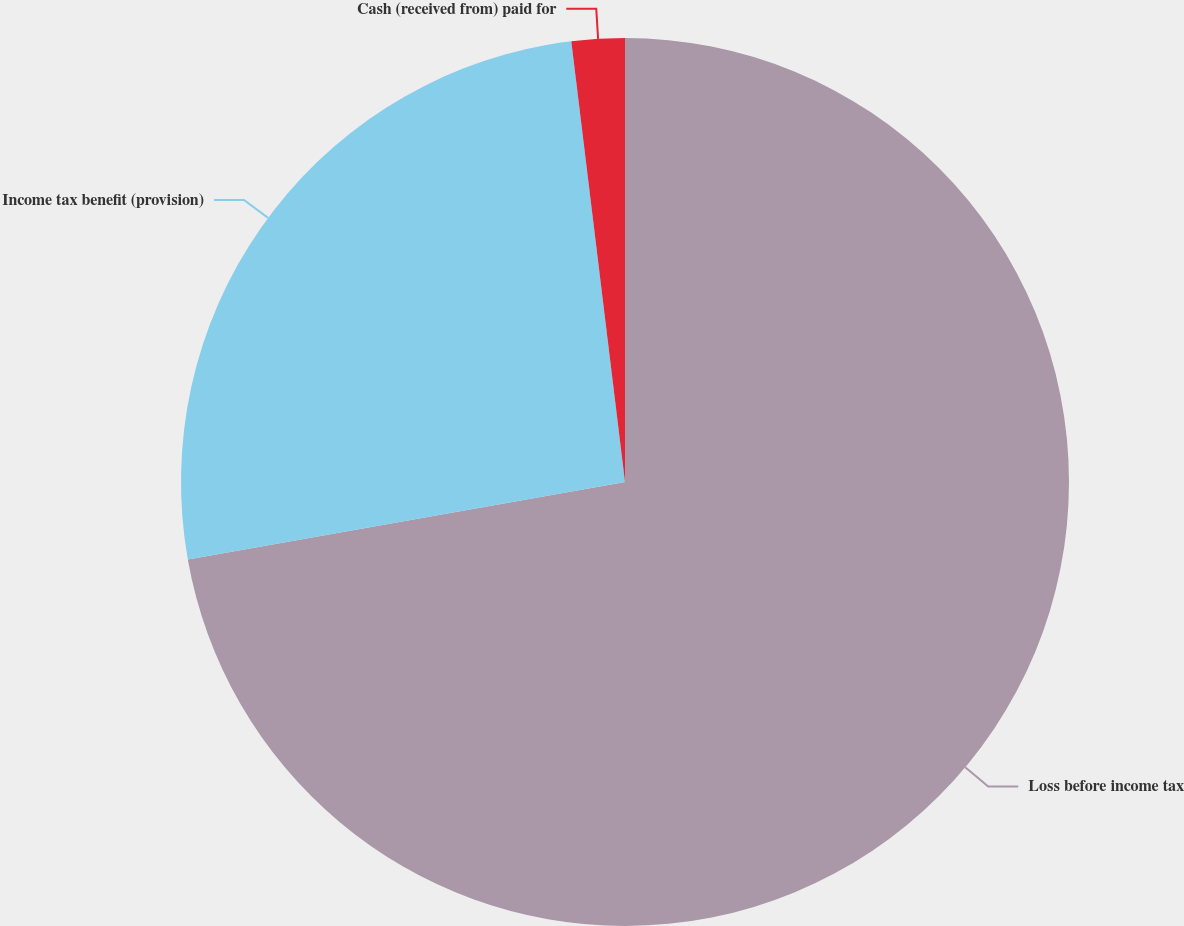Convert chart to OTSL. <chart><loc_0><loc_0><loc_500><loc_500><pie_chart><fcel>Loss before income tax<fcel>Income tax benefit (provision)<fcel>Cash (received from) paid for<nl><fcel>72.2%<fcel>25.86%<fcel>1.93%<nl></chart> 